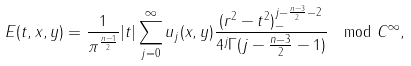Convert formula to latex. <formula><loc_0><loc_0><loc_500><loc_500>E ( t , x , y ) = \frac { 1 } { \pi ^ { \frac { n - 1 } { 2 } } } | t | \sum _ { j = 0 } ^ { \infty } u _ { j } ( x , y ) \frac { ( r ^ { 2 } - t ^ { 2 } ) _ { - } ^ { j - \frac { n - 3 } { 2 } - 2 } } { 4 ^ { j } \Gamma ( j - \frac { n - 3 } { 2 } - 1 ) } \mod C ^ { \infty } ,</formula> 